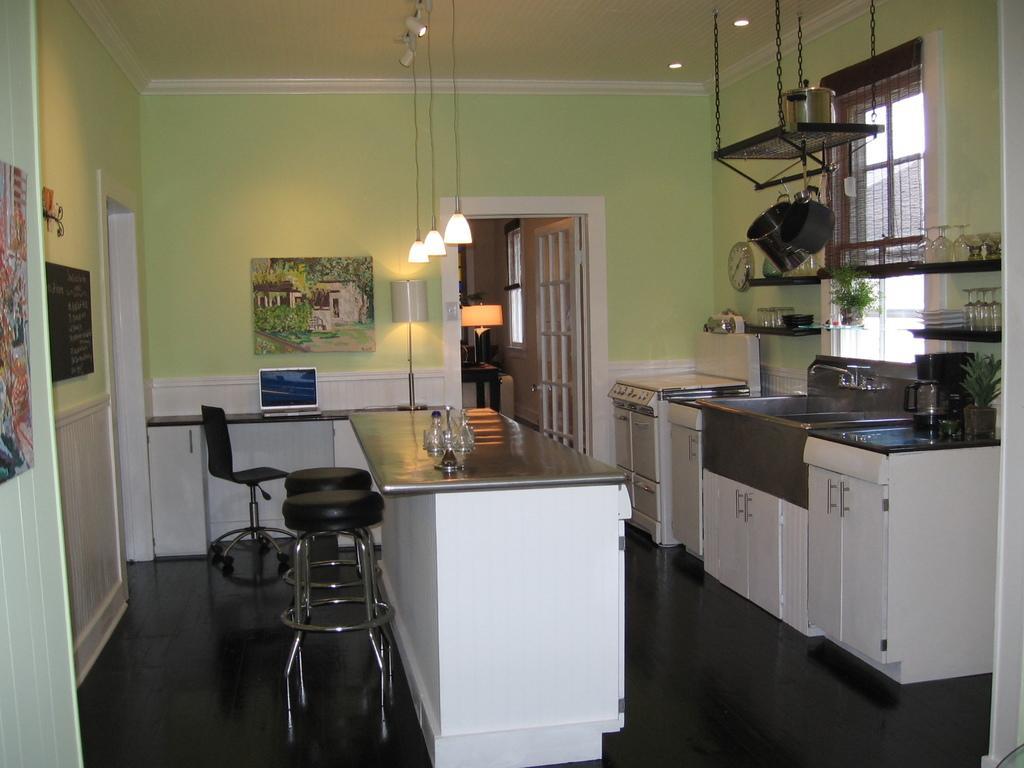Can you describe this image briefly? Picture inside of a kitchen. Right side of the image we can see clock, sink, cupboards, window, plant and shelves. On these shelves there are glasses. These are containers. This shelf is hanging in the air with chains. Middle of the image we can see table, chairs, lamp, lights, laptop, picture and glasses. Picture is on the green wall. Left side of the image we can see black board, picture and wall. Far we can see door, window, table and lantern lamp.  